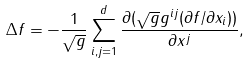Convert formula to latex. <formula><loc_0><loc_0><loc_500><loc_500>\Delta f = - \frac { 1 } { \sqrt { g } } \sum _ { i , j = 1 } ^ { d } \frac { \partial ( \sqrt { g } g ^ { i j } ( \partial f / \partial x _ { i } ) ) } { \partial x ^ { j } } ,</formula> 